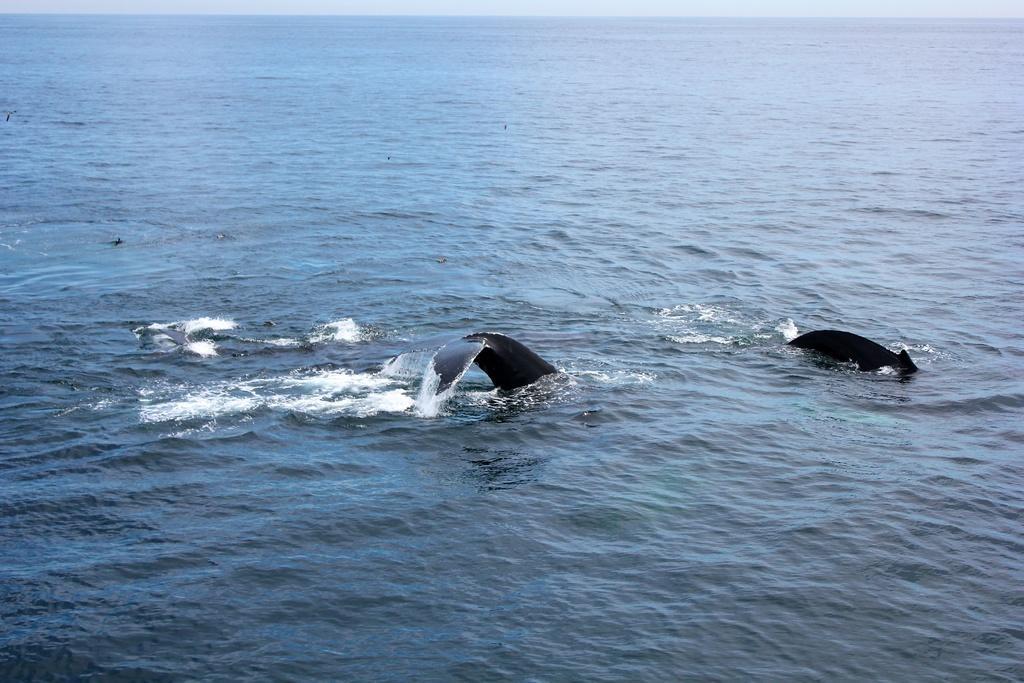Could you give a brief overview of what you see in this image? In this image we can see sea animals in the water. 